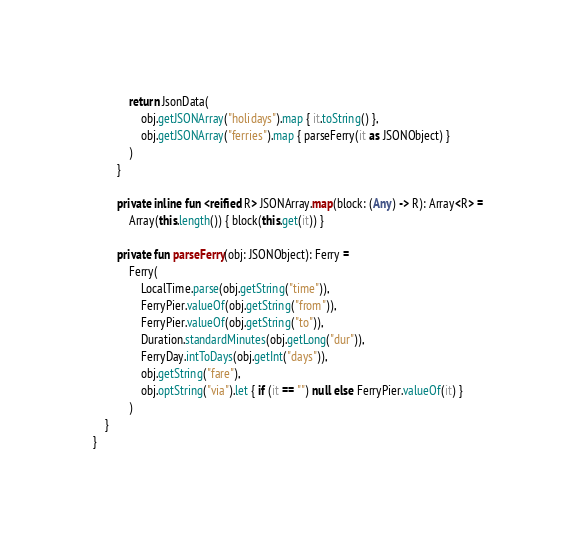Convert code to text. <code><loc_0><loc_0><loc_500><loc_500><_Kotlin_>            return JsonData(
                obj.getJSONArray("holidays").map { it.toString() },
                obj.getJSONArray("ferries").map { parseFerry(it as JSONObject) }
            )
        }

        private inline fun <reified R> JSONArray.map(block: (Any) -> R): Array<R> =
            Array(this.length()) { block(this.get(it)) }

        private fun parseFerry(obj: JSONObject): Ferry =
            Ferry(
                LocalTime.parse(obj.getString("time")),
                FerryPier.valueOf(obj.getString("from")),
                FerryPier.valueOf(obj.getString("to")),
                Duration.standardMinutes(obj.getLong("dur")),
                FerryDay.intToDays(obj.getInt("days")),
                obj.getString("fare"),
                obj.optString("via").let { if (it == "") null else FerryPier.valueOf(it) }
            )
    }
}
</code> 